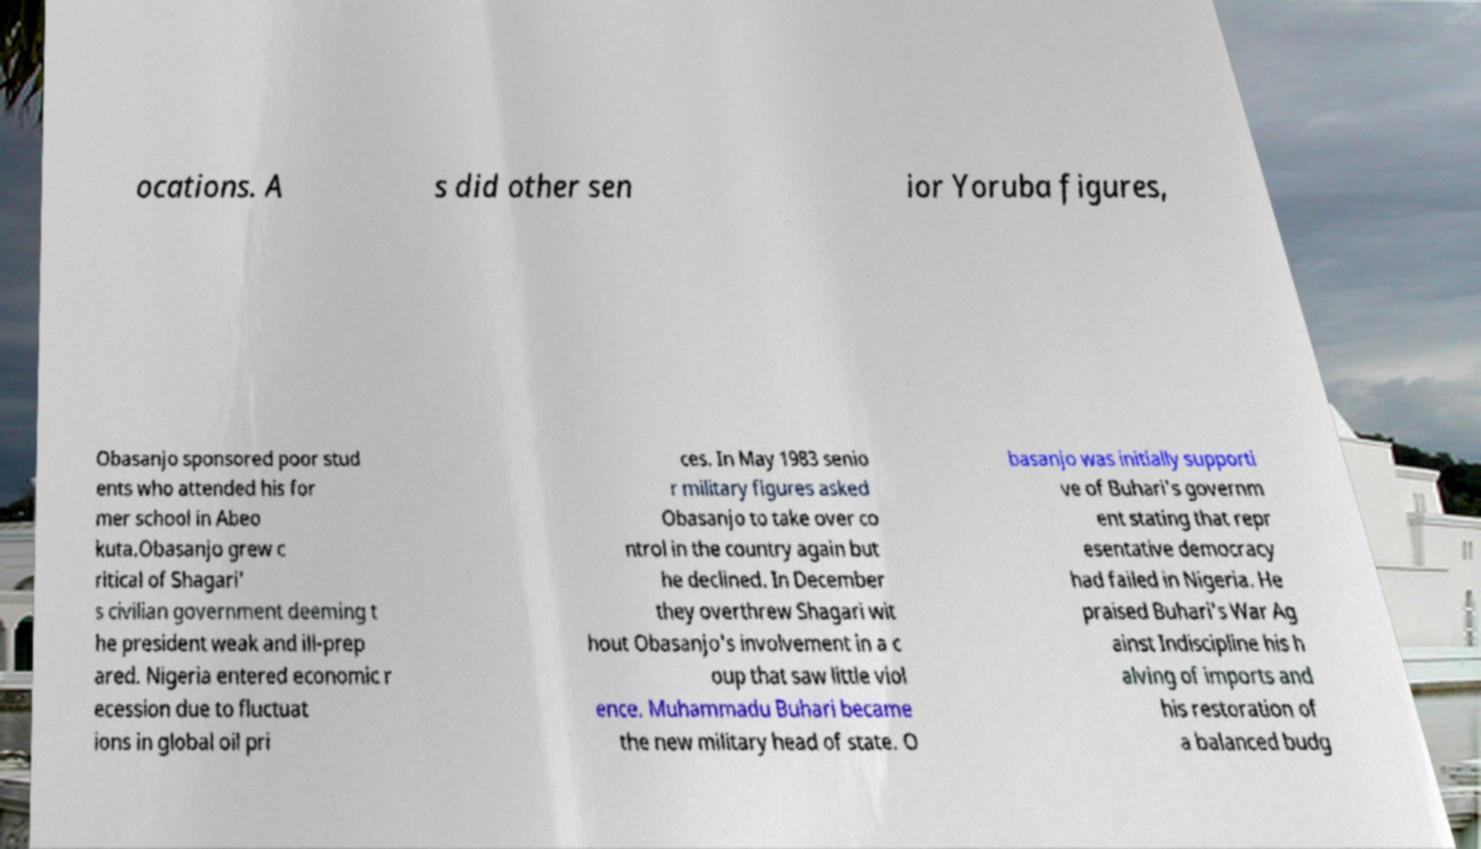Could you extract and type out the text from this image? ocations. A s did other sen ior Yoruba figures, Obasanjo sponsored poor stud ents who attended his for mer school in Abeo kuta.Obasanjo grew c ritical of Shagari' s civilian government deeming t he president weak and ill-prep ared. Nigeria entered economic r ecession due to fluctuat ions in global oil pri ces. In May 1983 senio r military figures asked Obasanjo to take over co ntrol in the country again but he declined. In December they overthrew Shagari wit hout Obasanjo's involvement in a c oup that saw little viol ence. Muhammadu Buhari became the new military head of state. O basanjo was initially supporti ve of Buhari's governm ent stating that repr esentative democracy had failed in Nigeria. He praised Buhari's War Ag ainst Indiscipline his h alving of imports and his restoration of a balanced budg 